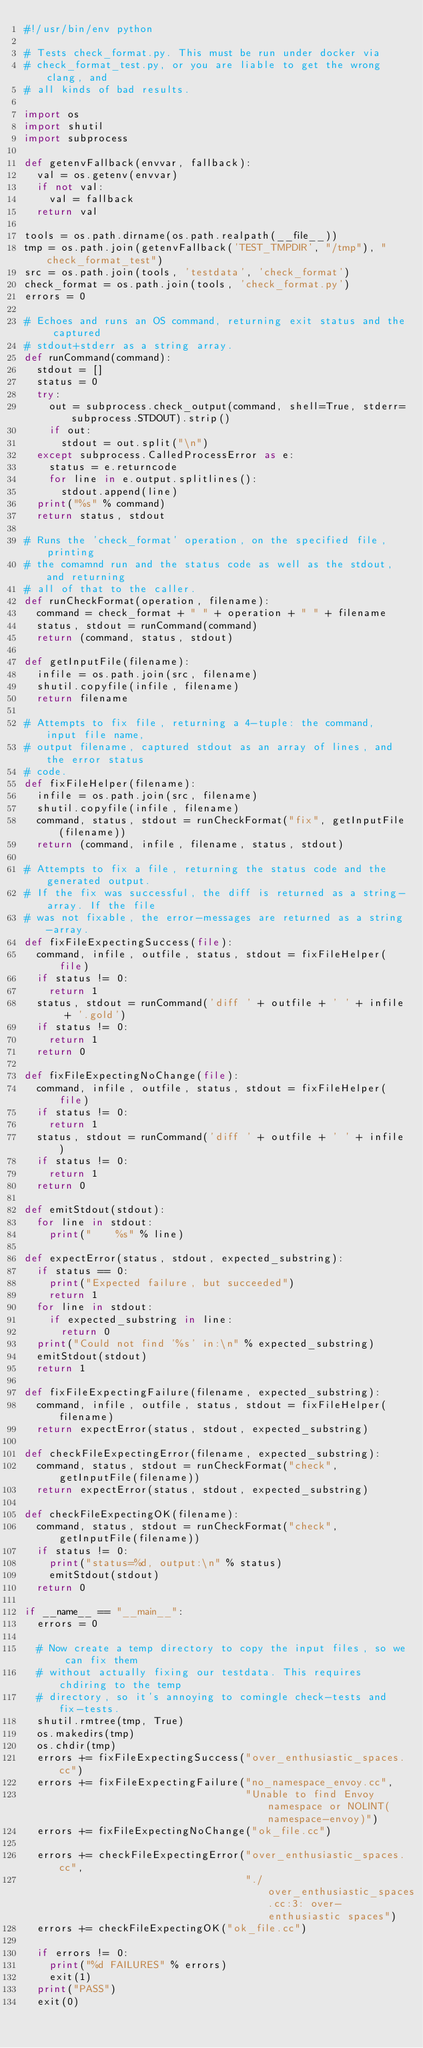<code> <loc_0><loc_0><loc_500><loc_500><_Python_>#!/usr/bin/env python

# Tests check_format.py. This must be run under docker via
# check_format_test.py, or you are liable to get the wrong clang, and
# all kinds of bad results.

import os
import shutil
import subprocess

def getenvFallback(envvar, fallback):
  val = os.getenv(envvar)
  if not val:
    val = fallback
  return val

tools = os.path.dirname(os.path.realpath(__file__))
tmp = os.path.join(getenvFallback('TEST_TMPDIR', "/tmp"), "check_format_test")
src = os.path.join(tools, 'testdata', 'check_format')
check_format = os.path.join(tools, 'check_format.py')
errors = 0

# Echoes and runs an OS command, returning exit status and the captured
# stdout+stderr as a string array.
def runCommand(command):
  stdout = []
  status = 0
  try:
    out = subprocess.check_output(command, shell=True, stderr=subprocess.STDOUT).strip()
    if out:
      stdout = out.split("\n")
  except subprocess.CalledProcessError as e:
    status = e.returncode
    for line in e.output.splitlines():
      stdout.append(line)
  print("%s" % command)
  return status, stdout

# Runs the 'check_format' operation, on the specified file, printing
# the comamnd run and the status code as well as the stdout, and returning
# all of that to the caller.
def runCheckFormat(operation, filename):
  command = check_format + " " + operation + " " + filename
  status, stdout = runCommand(command)
  return (command, status, stdout)

def getInputFile(filename):
  infile = os.path.join(src, filename)
  shutil.copyfile(infile, filename)
  return filename

# Attempts to fix file, returning a 4-tuple: the command, input file name,
# output filename, captured stdout as an array of lines, and the error status
# code.
def fixFileHelper(filename):
  infile = os.path.join(src, filename)
  shutil.copyfile(infile, filename)
  command, status, stdout = runCheckFormat("fix", getInputFile(filename))
  return (command, infile, filename, status, stdout)

# Attempts to fix a file, returning the status code and the generated output.
# If the fix was successful, the diff is returned as a string-array. If the file
# was not fixable, the error-messages are returned as a string-array.
def fixFileExpectingSuccess(file):
  command, infile, outfile, status, stdout = fixFileHelper(file)
  if status != 0:
    return 1
  status, stdout = runCommand('diff ' + outfile + ' ' + infile + '.gold')
  if status != 0:
    return 1
  return 0

def fixFileExpectingNoChange(file):
  command, infile, outfile, status, stdout = fixFileHelper(file)
  if status != 0:
    return 1
  status, stdout = runCommand('diff ' + outfile + ' ' + infile)
  if status != 0:
    return 1
  return 0

def emitStdout(stdout):
  for line in stdout:
    print("    %s" % line)

def expectError(status, stdout, expected_substring):
  if status == 0:
    print("Expected failure, but succeeded")
    return 1
  for line in stdout:
    if expected_substring in line:
      return 0
  print("Could not find '%s' in:\n" % expected_substring)
  emitStdout(stdout)
  return 1

def fixFileExpectingFailure(filename, expected_substring):
  command, infile, outfile, status, stdout = fixFileHelper(filename)
  return expectError(status, stdout, expected_substring)

def checkFileExpectingError(filename, expected_substring):
  command, status, stdout = runCheckFormat("check", getInputFile(filename))
  return expectError(status, stdout, expected_substring)

def checkFileExpectingOK(filename):
  command, status, stdout = runCheckFormat("check", getInputFile(filename))
  if status != 0:
    print("status=%d, output:\n" % status)
    emitStdout(stdout)
  return 0

if __name__ == "__main__":
  errors = 0

  # Now create a temp directory to copy the input files, so we can fix them
  # without actually fixing our testdata. This requires chdiring to the temp
  # directory, so it's annoying to comingle check-tests and fix-tests.
  shutil.rmtree(tmp, True)
  os.makedirs(tmp)
  os.chdir(tmp)
  errors += fixFileExpectingSuccess("over_enthusiastic_spaces.cc")
  errors += fixFileExpectingFailure("no_namespace_envoy.cc",
                                    "Unable to find Envoy namespace or NOLINT(namespace-envoy)")
  errors += fixFileExpectingNoChange("ok_file.cc")

  errors += checkFileExpectingError("over_enthusiastic_spaces.cc",
                                    "./over_enthusiastic_spaces.cc:3: over-enthusiastic spaces")
  errors += checkFileExpectingOK("ok_file.cc")

  if errors != 0:
    print("%d FAILURES" % errors)
    exit(1)
  print("PASS")
  exit(0)
</code> 